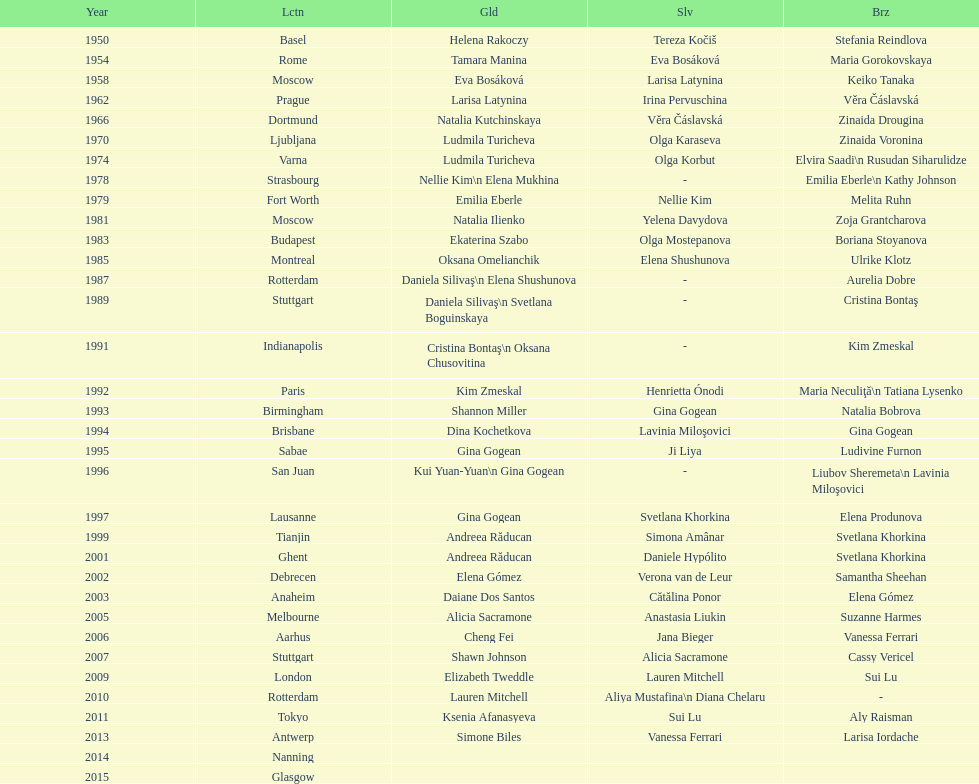Where were the championships held before the 1962 prague championships? Moscow. 